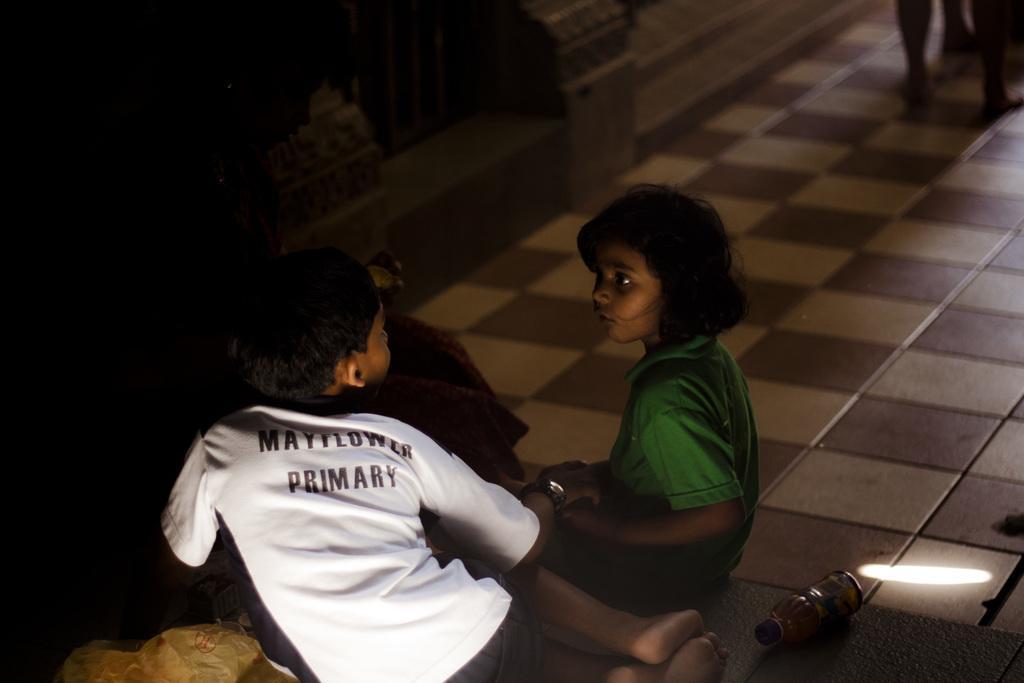In one or two sentences, can you explain what this image depicts? In this image we can see two kids wearing white and green color dress respectively sitting on floor and we can see cover, bottle and some other items on floor and in the background of the image there is a wall. 